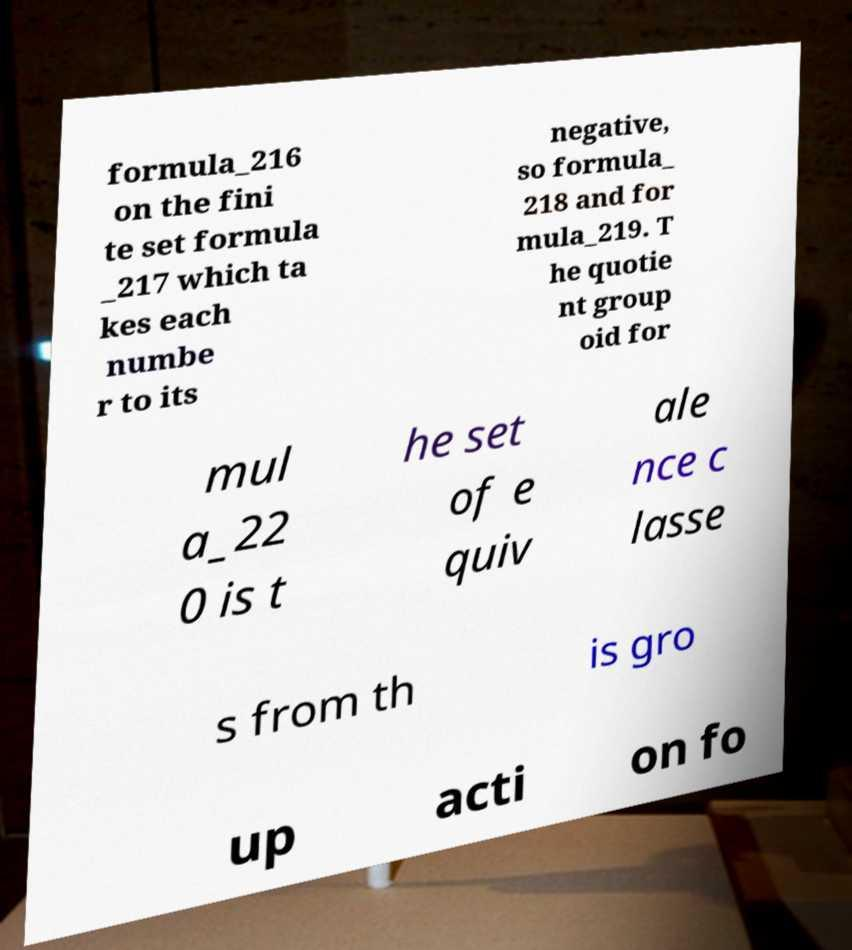Could you extract and type out the text from this image? formula_216 on the fini te set formula _217 which ta kes each numbe r to its negative, so formula_ 218 and for mula_219. T he quotie nt group oid for mul a_22 0 is t he set of e quiv ale nce c lasse s from th is gro up acti on fo 